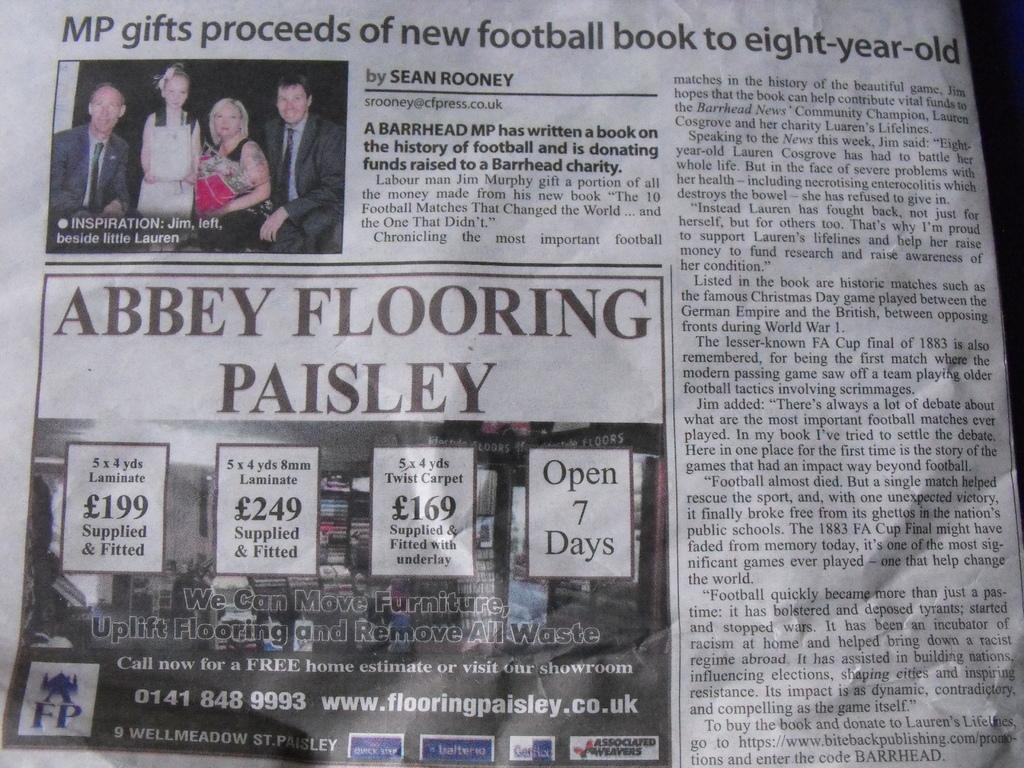What type of print material is visible in the image? There is a newspaper in the image. What can be found within the newspaper? The newspaper contains pictures, information, and numbers. Are there any people present in the image? Yes, there are people in the image. What time of day is depicted in the image, and what role does the father play in the scene? The provided facts do not mention the time of day or the presence of a father in the image. Therefore, we cannot determine the time of day or the role of a father in the scene. 